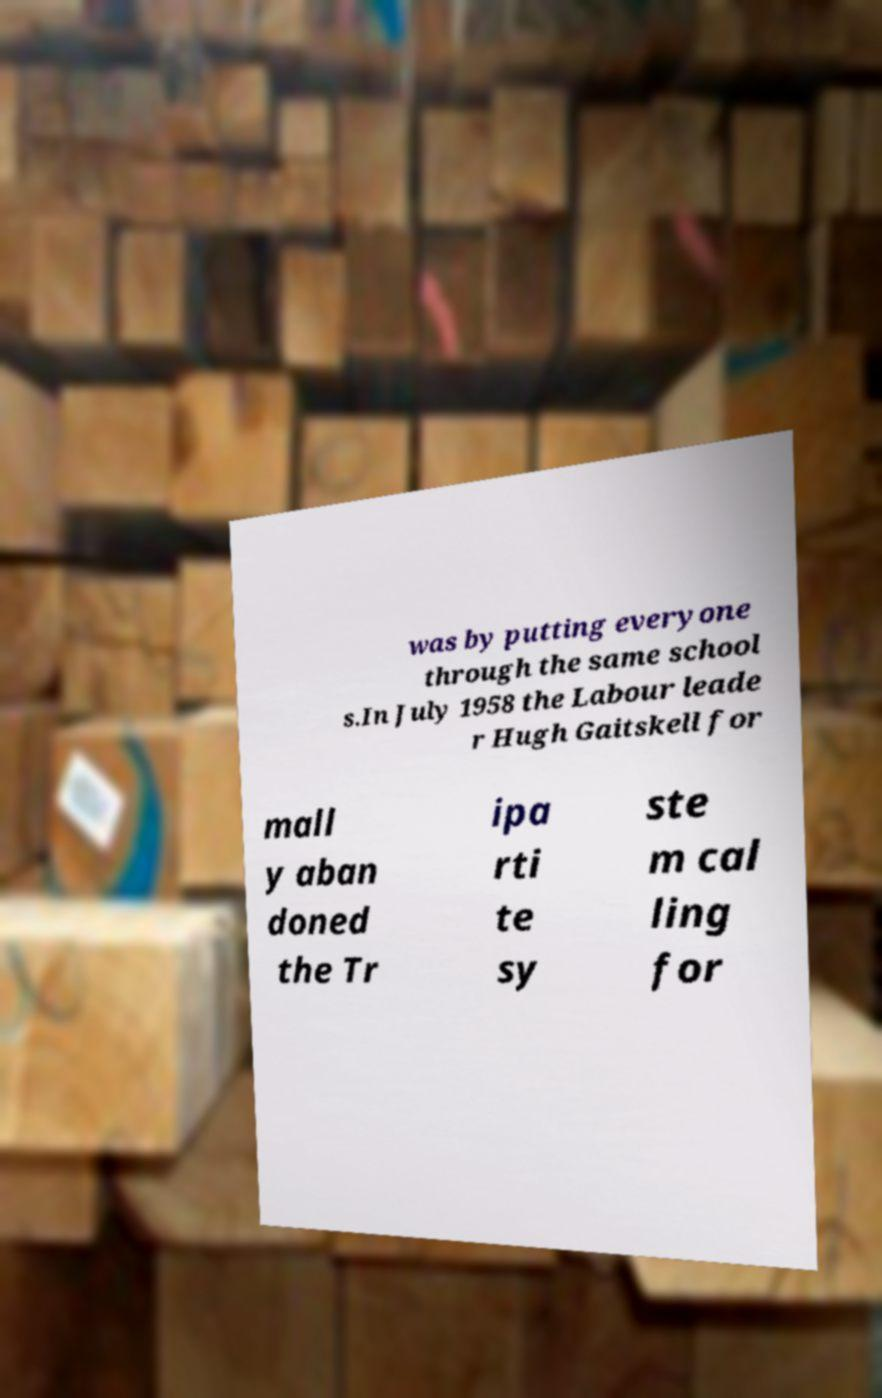Please read and relay the text visible in this image. What does it say? was by putting everyone through the same school s.In July 1958 the Labour leade r Hugh Gaitskell for mall y aban doned the Tr ipa rti te sy ste m cal ling for 